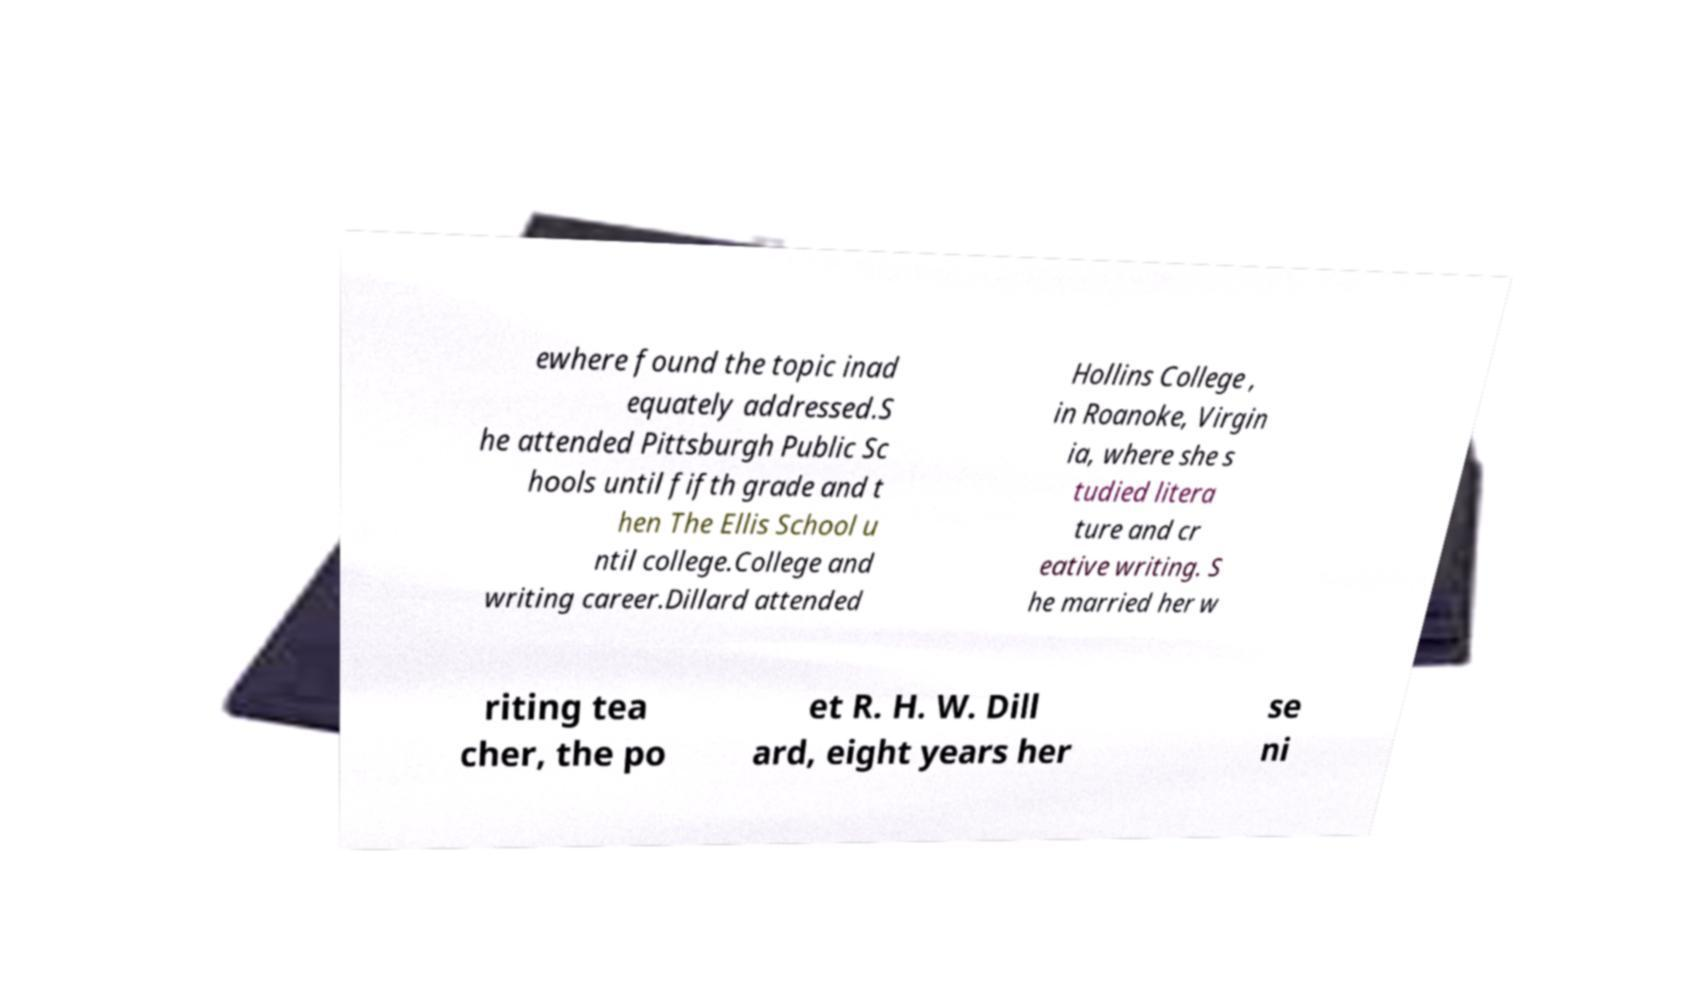There's text embedded in this image that I need extracted. Can you transcribe it verbatim? ewhere found the topic inad equately addressed.S he attended Pittsburgh Public Sc hools until fifth grade and t hen The Ellis School u ntil college.College and writing career.Dillard attended Hollins College , in Roanoke, Virgin ia, where she s tudied litera ture and cr eative writing. S he married her w riting tea cher, the po et R. H. W. Dill ard, eight years her se ni 